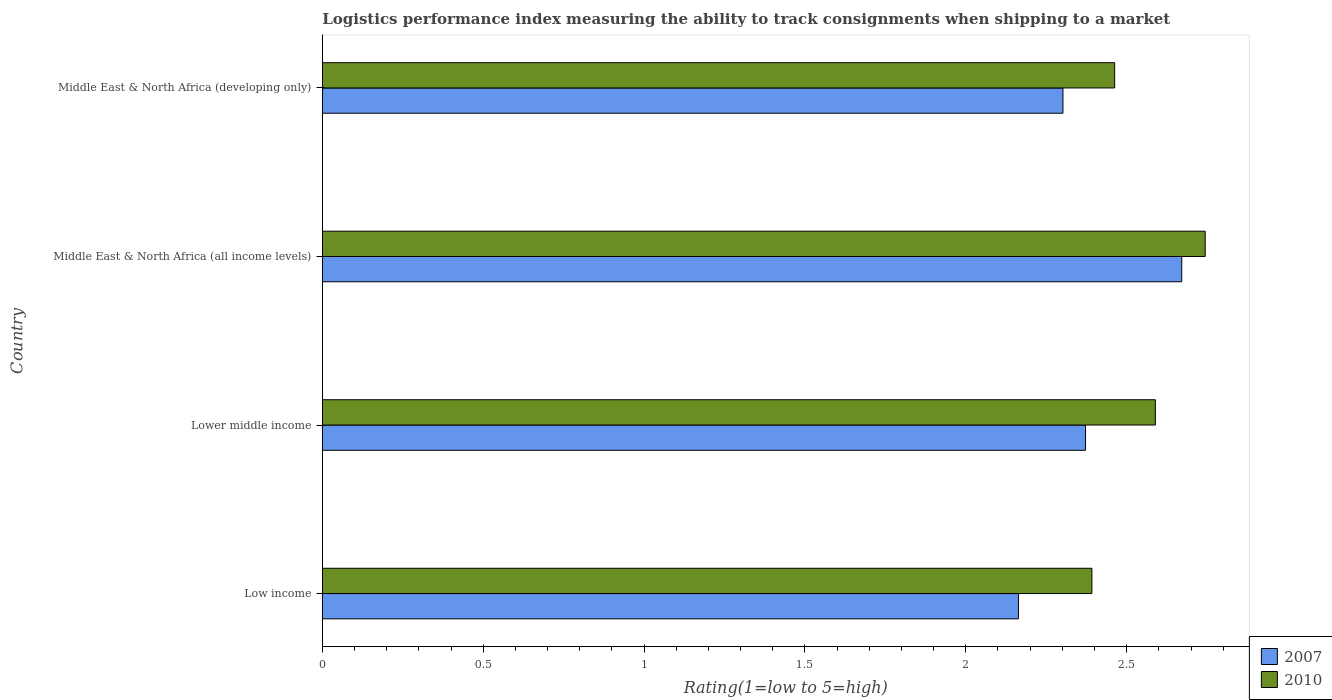Are the number of bars per tick equal to the number of legend labels?
Your answer should be very brief. Yes. How many bars are there on the 1st tick from the top?
Your answer should be very brief. 2. What is the label of the 1st group of bars from the top?
Your answer should be very brief. Middle East & North Africa (developing only). In how many cases, is the number of bars for a given country not equal to the number of legend labels?
Offer a very short reply. 0. What is the Logistic performance index in 2007 in Lower middle income?
Provide a succinct answer. 2.37. Across all countries, what is the maximum Logistic performance index in 2010?
Your response must be concise. 2.74. Across all countries, what is the minimum Logistic performance index in 2007?
Ensure brevity in your answer.  2.16. In which country was the Logistic performance index in 2010 maximum?
Provide a short and direct response. Middle East & North Africa (all income levels). In which country was the Logistic performance index in 2007 minimum?
Ensure brevity in your answer.  Low income. What is the total Logistic performance index in 2010 in the graph?
Your answer should be compact. 10.19. What is the difference between the Logistic performance index in 2010 in Low income and that in Lower middle income?
Provide a short and direct response. -0.2. What is the difference between the Logistic performance index in 2010 in Lower middle income and the Logistic performance index in 2007 in Middle East & North Africa (developing only)?
Provide a succinct answer. 0.29. What is the average Logistic performance index in 2010 per country?
Ensure brevity in your answer.  2.55. What is the difference between the Logistic performance index in 2007 and Logistic performance index in 2010 in Lower middle income?
Ensure brevity in your answer.  -0.22. What is the ratio of the Logistic performance index in 2010 in Low income to that in Lower middle income?
Provide a short and direct response. 0.92. Is the difference between the Logistic performance index in 2007 in Lower middle income and Middle East & North Africa (developing only) greater than the difference between the Logistic performance index in 2010 in Lower middle income and Middle East & North Africa (developing only)?
Offer a very short reply. No. What is the difference between the highest and the second highest Logistic performance index in 2007?
Offer a very short reply. 0.3. What is the difference between the highest and the lowest Logistic performance index in 2010?
Keep it short and to the point. 0.35. Is the sum of the Logistic performance index in 2010 in Low income and Middle East & North Africa (all income levels) greater than the maximum Logistic performance index in 2007 across all countries?
Give a very brief answer. Yes. What does the 2nd bar from the bottom in Middle East & North Africa (developing only) represents?
Your answer should be compact. 2010. How many bars are there?
Provide a succinct answer. 8. Are all the bars in the graph horizontal?
Offer a very short reply. Yes. What is the difference between two consecutive major ticks on the X-axis?
Offer a terse response. 0.5. Does the graph contain any zero values?
Offer a terse response. No. Does the graph contain grids?
Provide a short and direct response. No. What is the title of the graph?
Provide a succinct answer. Logistics performance index measuring the ability to track consignments when shipping to a market. Does "2010" appear as one of the legend labels in the graph?
Your answer should be very brief. Yes. What is the label or title of the X-axis?
Provide a short and direct response. Rating(1=low to 5=high). What is the label or title of the Y-axis?
Offer a very short reply. Country. What is the Rating(1=low to 5=high) of 2007 in Low income?
Your answer should be very brief. 2.16. What is the Rating(1=low to 5=high) of 2010 in Low income?
Your answer should be compact. 2.39. What is the Rating(1=low to 5=high) of 2007 in Lower middle income?
Your answer should be compact. 2.37. What is the Rating(1=low to 5=high) of 2010 in Lower middle income?
Keep it short and to the point. 2.59. What is the Rating(1=low to 5=high) in 2007 in Middle East & North Africa (all income levels)?
Your answer should be compact. 2.67. What is the Rating(1=low to 5=high) of 2010 in Middle East & North Africa (all income levels)?
Make the answer very short. 2.74. What is the Rating(1=low to 5=high) in 2007 in Middle East & North Africa (developing only)?
Offer a very short reply. 2.3. What is the Rating(1=low to 5=high) in 2010 in Middle East & North Africa (developing only)?
Ensure brevity in your answer.  2.46. Across all countries, what is the maximum Rating(1=low to 5=high) in 2007?
Give a very brief answer. 2.67. Across all countries, what is the maximum Rating(1=low to 5=high) of 2010?
Offer a very short reply. 2.74. Across all countries, what is the minimum Rating(1=low to 5=high) of 2007?
Ensure brevity in your answer.  2.16. Across all countries, what is the minimum Rating(1=low to 5=high) of 2010?
Provide a succinct answer. 2.39. What is the total Rating(1=low to 5=high) in 2007 in the graph?
Make the answer very short. 9.51. What is the total Rating(1=low to 5=high) of 2010 in the graph?
Ensure brevity in your answer.  10.19. What is the difference between the Rating(1=low to 5=high) of 2007 in Low income and that in Lower middle income?
Make the answer very short. -0.21. What is the difference between the Rating(1=low to 5=high) in 2010 in Low income and that in Lower middle income?
Keep it short and to the point. -0.2. What is the difference between the Rating(1=low to 5=high) in 2007 in Low income and that in Middle East & North Africa (all income levels)?
Your response must be concise. -0.51. What is the difference between the Rating(1=low to 5=high) in 2010 in Low income and that in Middle East & North Africa (all income levels)?
Make the answer very short. -0.35. What is the difference between the Rating(1=low to 5=high) in 2007 in Low income and that in Middle East & North Africa (developing only)?
Provide a short and direct response. -0.14. What is the difference between the Rating(1=low to 5=high) in 2010 in Low income and that in Middle East & North Africa (developing only)?
Your answer should be compact. -0.07. What is the difference between the Rating(1=low to 5=high) of 2007 in Lower middle income and that in Middle East & North Africa (all income levels)?
Provide a succinct answer. -0.3. What is the difference between the Rating(1=low to 5=high) of 2010 in Lower middle income and that in Middle East & North Africa (all income levels)?
Provide a short and direct response. -0.15. What is the difference between the Rating(1=low to 5=high) in 2007 in Lower middle income and that in Middle East & North Africa (developing only)?
Make the answer very short. 0.07. What is the difference between the Rating(1=low to 5=high) in 2010 in Lower middle income and that in Middle East & North Africa (developing only)?
Make the answer very short. 0.13. What is the difference between the Rating(1=low to 5=high) in 2007 in Middle East & North Africa (all income levels) and that in Middle East & North Africa (developing only)?
Provide a succinct answer. 0.37. What is the difference between the Rating(1=low to 5=high) in 2010 in Middle East & North Africa (all income levels) and that in Middle East & North Africa (developing only)?
Keep it short and to the point. 0.28. What is the difference between the Rating(1=low to 5=high) in 2007 in Low income and the Rating(1=low to 5=high) in 2010 in Lower middle income?
Offer a very short reply. -0.43. What is the difference between the Rating(1=low to 5=high) of 2007 in Low income and the Rating(1=low to 5=high) of 2010 in Middle East & North Africa (all income levels)?
Keep it short and to the point. -0.58. What is the difference between the Rating(1=low to 5=high) of 2007 in Low income and the Rating(1=low to 5=high) of 2010 in Middle East & North Africa (developing only)?
Make the answer very short. -0.3. What is the difference between the Rating(1=low to 5=high) in 2007 in Lower middle income and the Rating(1=low to 5=high) in 2010 in Middle East & North Africa (all income levels)?
Ensure brevity in your answer.  -0.37. What is the difference between the Rating(1=low to 5=high) in 2007 in Lower middle income and the Rating(1=low to 5=high) in 2010 in Middle East & North Africa (developing only)?
Your response must be concise. -0.09. What is the difference between the Rating(1=low to 5=high) of 2007 in Middle East & North Africa (all income levels) and the Rating(1=low to 5=high) of 2010 in Middle East & North Africa (developing only)?
Make the answer very short. 0.21. What is the average Rating(1=low to 5=high) in 2007 per country?
Ensure brevity in your answer.  2.38. What is the average Rating(1=low to 5=high) in 2010 per country?
Give a very brief answer. 2.55. What is the difference between the Rating(1=low to 5=high) in 2007 and Rating(1=low to 5=high) in 2010 in Low income?
Give a very brief answer. -0.23. What is the difference between the Rating(1=low to 5=high) in 2007 and Rating(1=low to 5=high) in 2010 in Lower middle income?
Offer a terse response. -0.22. What is the difference between the Rating(1=low to 5=high) in 2007 and Rating(1=low to 5=high) in 2010 in Middle East & North Africa (all income levels)?
Provide a succinct answer. -0.07. What is the difference between the Rating(1=low to 5=high) of 2007 and Rating(1=low to 5=high) of 2010 in Middle East & North Africa (developing only)?
Your answer should be compact. -0.16. What is the ratio of the Rating(1=low to 5=high) of 2007 in Low income to that in Lower middle income?
Give a very brief answer. 0.91. What is the ratio of the Rating(1=low to 5=high) of 2010 in Low income to that in Lower middle income?
Provide a short and direct response. 0.92. What is the ratio of the Rating(1=low to 5=high) of 2007 in Low income to that in Middle East & North Africa (all income levels)?
Your answer should be very brief. 0.81. What is the ratio of the Rating(1=low to 5=high) in 2010 in Low income to that in Middle East & North Africa (all income levels)?
Give a very brief answer. 0.87. What is the ratio of the Rating(1=low to 5=high) in 2007 in Low income to that in Middle East & North Africa (developing only)?
Provide a succinct answer. 0.94. What is the ratio of the Rating(1=low to 5=high) of 2010 in Low income to that in Middle East & North Africa (developing only)?
Provide a succinct answer. 0.97. What is the ratio of the Rating(1=low to 5=high) in 2007 in Lower middle income to that in Middle East & North Africa (all income levels)?
Your answer should be very brief. 0.89. What is the ratio of the Rating(1=low to 5=high) of 2010 in Lower middle income to that in Middle East & North Africa (all income levels)?
Offer a very short reply. 0.94. What is the ratio of the Rating(1=low to 5=high) in 2007 in Lower middle income to that in Middle East & North Africa (developing only)?
Keep it short and to the point. 1.03. What is the ratio of the Rating(1=low to 5=high) of 2010 in Lower middle income to that in Middle East & North Africa (developing only)?
Provide a succinct answer. 1.05. What is the ratio of the Rating(1=low to 5=high) in 2007 in Middle East & North Africa (all income levels) to that in Middle East & North Africa (developing only)?
Make the answer very short. 1.16. What is the ratio of the Rating(1=low to 5=high) of 2010 in Middle East & North Africa (all income levels) to that in Middle East & North Africa (developing only)?
Your answer should be very brief. 1.11. What is the difference between the highest and the second highest Rating(1=low to 5=high) in 2007?
Offer a terse response. 0.3. What is the difference between the highest and the second highest Rating(1=low to 5=high) of 2010?
Ensure brevity in your answer.  0.15. What is the difference between the highest and the lowest Rating(1=low to 5=high) in 2007?
Your answer should be very brief. 0.51. What is the difference between the highest and the lowest Rating(1=low to 5=high) in 2010?
Provide a short and direct response. 0.35. 